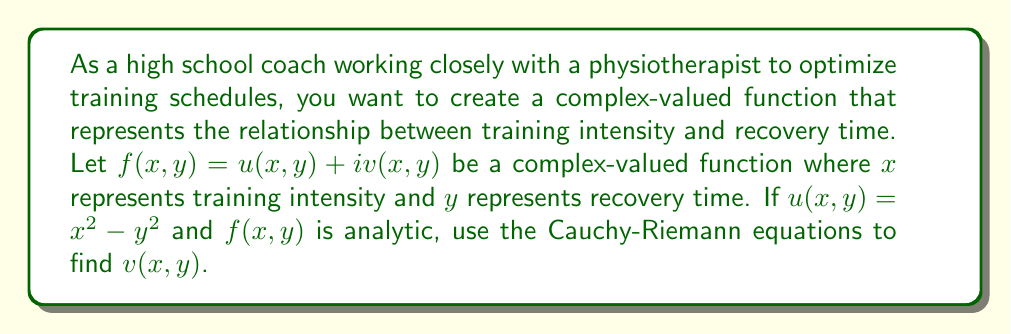Can you answer this question? To solve this problem, we'll use the Cauchy-Riemann equations and the given information about $u(x,y)$ to determine $v(x,y)$. Here's a step-by-step approach:

1. Recall the Cauchy-Riemann equations for a complex-valued function $f(x,y) = u(x,y) + iv(x,y)$ to be analytic:

   $$\frac{\partial u}{\partial x} = \frac{\partial v}{\partial y}$$ and $$\frac{\partial u}{\partial y} = -\frac{\partial v}{\partial x}$$

2. Given $u(x,y) = x^2 - y^2$, let's find its partial derivatives:

   $$\frac{\partial u}{\partial x} = 2x$$
   $$\frac{\partial u}{\partial y} = -2y$$

3. Using the first Cauchy-Riemann equation:

   $$\frac{\partial v}{\partial y} = \frac{\partial u}{\partial x} = 2x$$

4. Integrating with respect to $y$:

   $$v(x,y) = \int 2x dy = 2xy + h(x)$$

   where $h(x)$ is some function of $x$ only.

5. Now, using the second Cauchy-Riemann equation:

   $$\frac{\partial v}{\partial x} = -\frac{\partial u}{\partial y} = 2y$$

6. Taking the partial derivative of $v(x,y)$ with respect to $x$:

   $$\frac{\partial v}{\partial x} = 2y + h'(x) = 2y$$

7. This implies that $h'(x) = 0$, so $h(x)$ must be a constant. We can choose this constant to be 0 without loss of generality.

Therefore, the function $v(x,y)$ that satisfies the Cauchy-Riemann equations for the given $u(x,y)$ is:

$$v(x,y) = 2xy$$
Answer: $v(x,y) = 2xy$ 